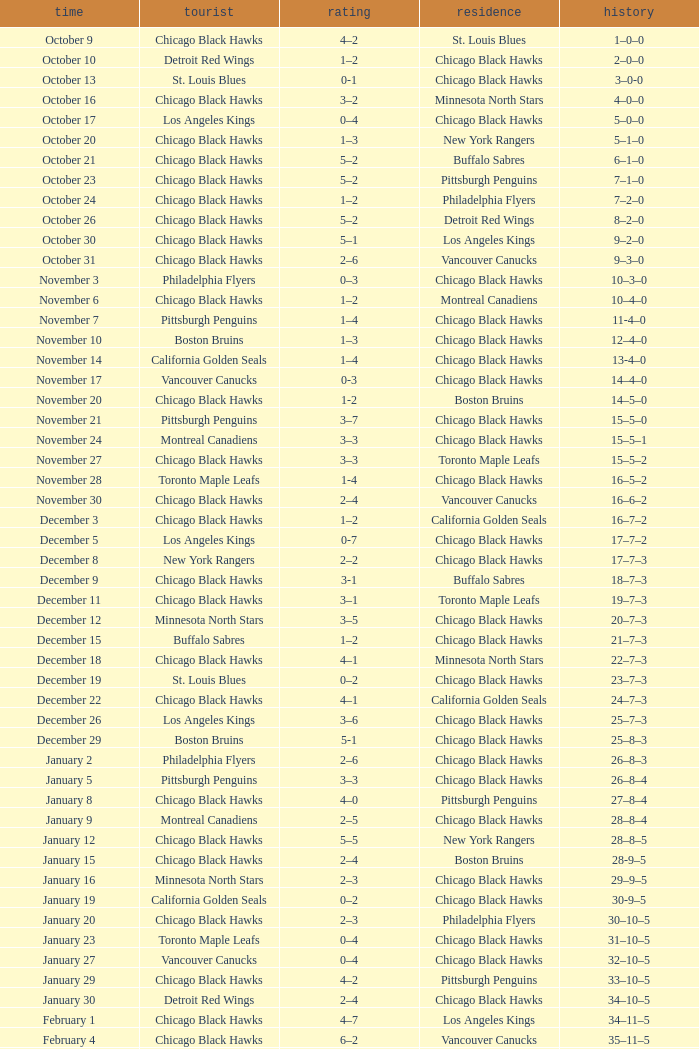What is the Score of the Chicago Black Hawks Home game with the Visiting Vancouver Canucks on November 17? 0-3. 